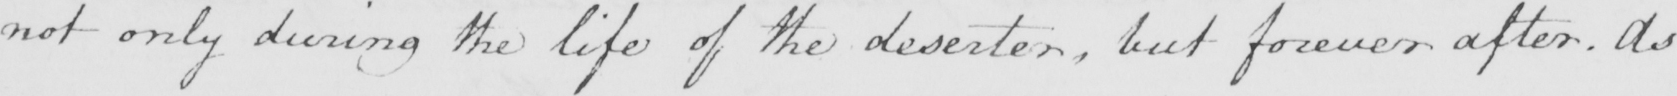Please transcribe the handwritten text in this image. not only during the life of the deserter , but forever after . As 